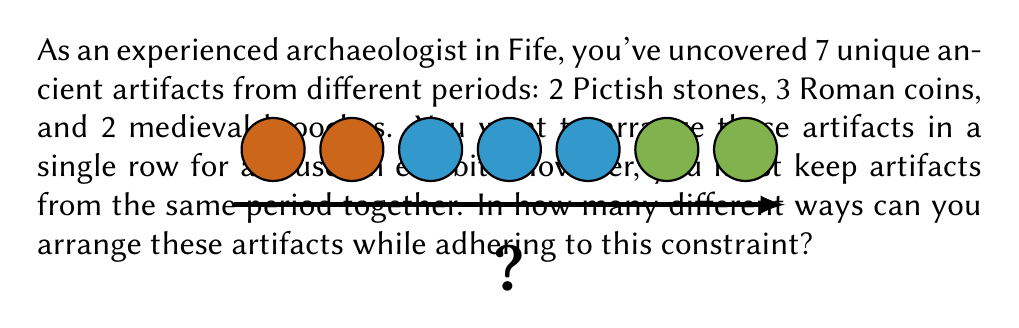Give your solution to this math problem. Let's approach this step-by-step:

1) First, we need to understand that we're dealing with three groups of artifacts that must stay together:
   - 2 Pictish stones
   - 3 Roman coins
   - 2 medieval brooches

2) We can think of this as arranging 3 distinct groups, rather than 7 individual artifacts.

3) The number of ways to arrange 3 distinct groups is simply 3! (3 factorial):

   $$ 3! = 3 \times 2 \times 1 = 6 $$

4) However, within each group, the artifacts can also be arranged in different ways:
   - The 2 Pictish stones can be arranged in 2! ways
   - The 3 Roman coins can be arranged in 3! ways
   - The 2 medieval brooches can be arranged in 2! ways

5) By the multiplication principle, we multiply all these possibilities together:

   $$ 3! \times 2! \times 3! \times 2! $$

6) Let's calculate this:
   $$ 6 \times 2 \times 6 \times 2 = 144 $$

Therefore, there are 144 different ways to arrange these artifacts while keeping items from the same period together.
Answer: 144 